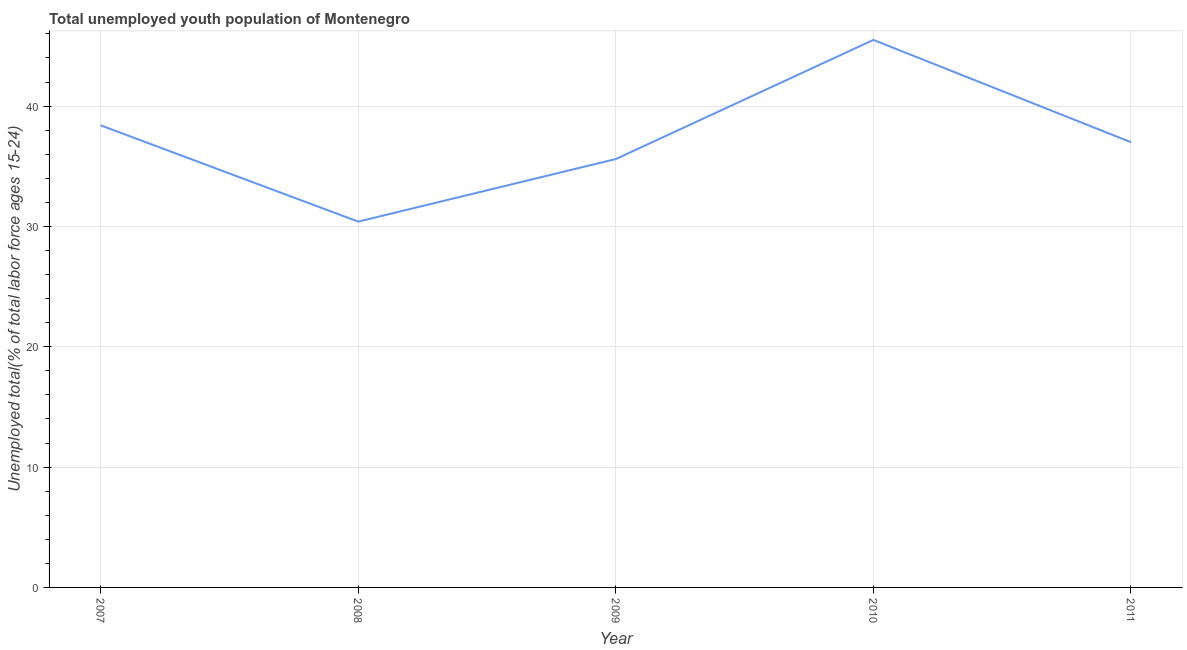What is the unemployed youth in 2010?
Offer a very short reply. 45.5. Across all years, what is the maximum unemployed youth?
Your answer should be very brief. 45.5. Across all years, what is the minimum unemployed youth?
Keep it short and to the point. 30.4. In which year was the unemployed youth minimum?
Ensure brevity in your answer.  2008. What is the sum of the unemployed youth?
Provide a short and direct response. 186.9. What is the difference between the unemployed youth in 2007 and 2010?
Provide a succinct answer. -7.1. What is the average unemployed youth per year?
Make the answer very short. 37.38. What is the median unemployed youth?
Offer a very short reply. 37. In how many years, is the unemployed youth greater than 38 %?
Offer a very short reply. 2. Do a majority of the years between 2009 and 2007 (inclusive) have unemployed youth greater than 6 %?
Offer a very short reply. No. What is the ratio of the unemployed youth in 2007 to that in 2009?
Give a very brief answer. 1.08. Is the difference between the unemployed youth in 2007 and 2011 greater than the difference between any two years?
Ensure brevity in your answer.  No. What is the difference between the highest and the second highest unemployed youth?
Give a very brief answer. 7.1. Is the sum of the unemployed youth in 2009 and 2011 greater than the maximum unemployed youth across all years?
Offer a very short reply. Yes. What is the difference between the highest and the lowest unemployed youth?
Ensure brevity in your answer.  15.1. In how many years, is the unemployed youth greater than the average unemployed youth taken over all years?
Provide a succinct answer. 2. Does the unemployed youth monotonically increase over the years?
Your response must be concise. No. How many lines are there?
Your answer should be very brief. 1. Are the values on the major ticks of Y-axis written in scientific E-notation?
Offer a terse response. No. Does the graph contain grids?
Keep it short and to the point. Yes. What is the title of the graph?
Keep it short and to the point. Total unemployed youth population of Montenegro. What is the label or title of the X-axis?
Provide a succinct answer. Year. What is the label or title of the Y-axis?
Your answer should be compact. Unemployed total(% of total labor force ages 15-24). What is the Unemployed total(% of total labor force ages 15-24) of 2007?
Give a very brief answer. 38.4. What is the Unemployed total(% of total labor force ages 15-24) in 2008?
Ensure brevity in your answer.  30.4. What is the Unemployed total(% of total labor force ages 15-24) in 2009?
Keep it short and to the point. 35.6. What is the Unemployed total(% of total labor force ages 15-24) of 2010?
Give a very brief answer. 45.5. What is the Unemployed total(% of total labor force ages 15-24) of 2011?
Your response must be concise. 37. What is the difference between the Unemployed total(% of total labor force ages 15-24) in 2007 and 2008?
Ensure brevity in your answer.  8. What is the difference between the Unemployed total(% of total labor force ages 15-24) in 2007 and 2010?
Your response must be concise. -7.1. What is the difference between the Unemployed total(% of total labor force ages 15-24) in 2007 and 2011?
Your response must be concise. 1.4. What is the difference between the Unemployed total(% of total labor force ages 15-24) in 2008 and 2010?
Your answer should be compact. -15.1. What is the difference between the Unemployed total(% of total labor force ages 15-24) in 2008 and 2011?
Ensure brevity in your answer.  -6.6. What is the difference between the Unemployed total(% of total labor force ages 15-24) in 2009 and 2010?
Give a very brief answer. -9.9. What is the difference between the Unemployed total(% of total labor force ages 15-24) in 2009 and 2011?
Ensure brevity in your answer.  -1.4. What is the ratio of the Unemployed total(% of total labor force ages 15-24) in 2007 to that in 2008?
Keep it short and to the point. 1.26. What is the ratio of the Unemployed total(% of total labor force ages 15-24) in 2007 to that in 2009?
Offer a terse response. 1.08. What is the ratio of the Unemployed total(% of total labor force ages 15-24) in 2007 to that in 2010?
Your answer should be compact. 0.84. What is the ratio of the Unemployed total(% of total labor force ages 15-24) in 2007 to that in 2011?
Provide a succinct answer. 1.04. What is the ratio of the Unemployed total(% of total labor force ages 15-24) in 2008 to that in 2009?
Provide a succinct answer. 0.85. What is the ratio of the Unemployed total(% of total labor force ages 15-24) in 2008 to that in 2010?
Make the answer very short. 0.67. What is the ratio of the Unemployed total(% of total labor force ages 15-24) in 2008 to that in 2011?
Your answer should be compact. 0.82. What is the ratio of the Unemployed total(% of total labor force ages 15-24) in 2009 to that in 2010?
Your answer should be compact. 0.78. What is the ratio of the Unemployed total(% of total labor force ages 15-24) in 2010 to that in 2011?
Give a very brief answer. 1.23. 